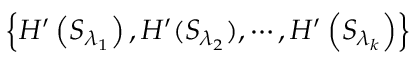Convert formula to latex. <formula><loc_0><loc_0><loc_500><loc_500>\left \{ H ^ { \prime } \left ( { { S } _ { { \lambda } _ { 1 } } } \right ) , H ^ { \prime } ( { { S } _ { { \lambda } _ { 2 } } } ) , \cdots , H ^ { \prime } \left ( { { S } _ { { \lambda } _ { k } } } \right ) \right \}</formula> 